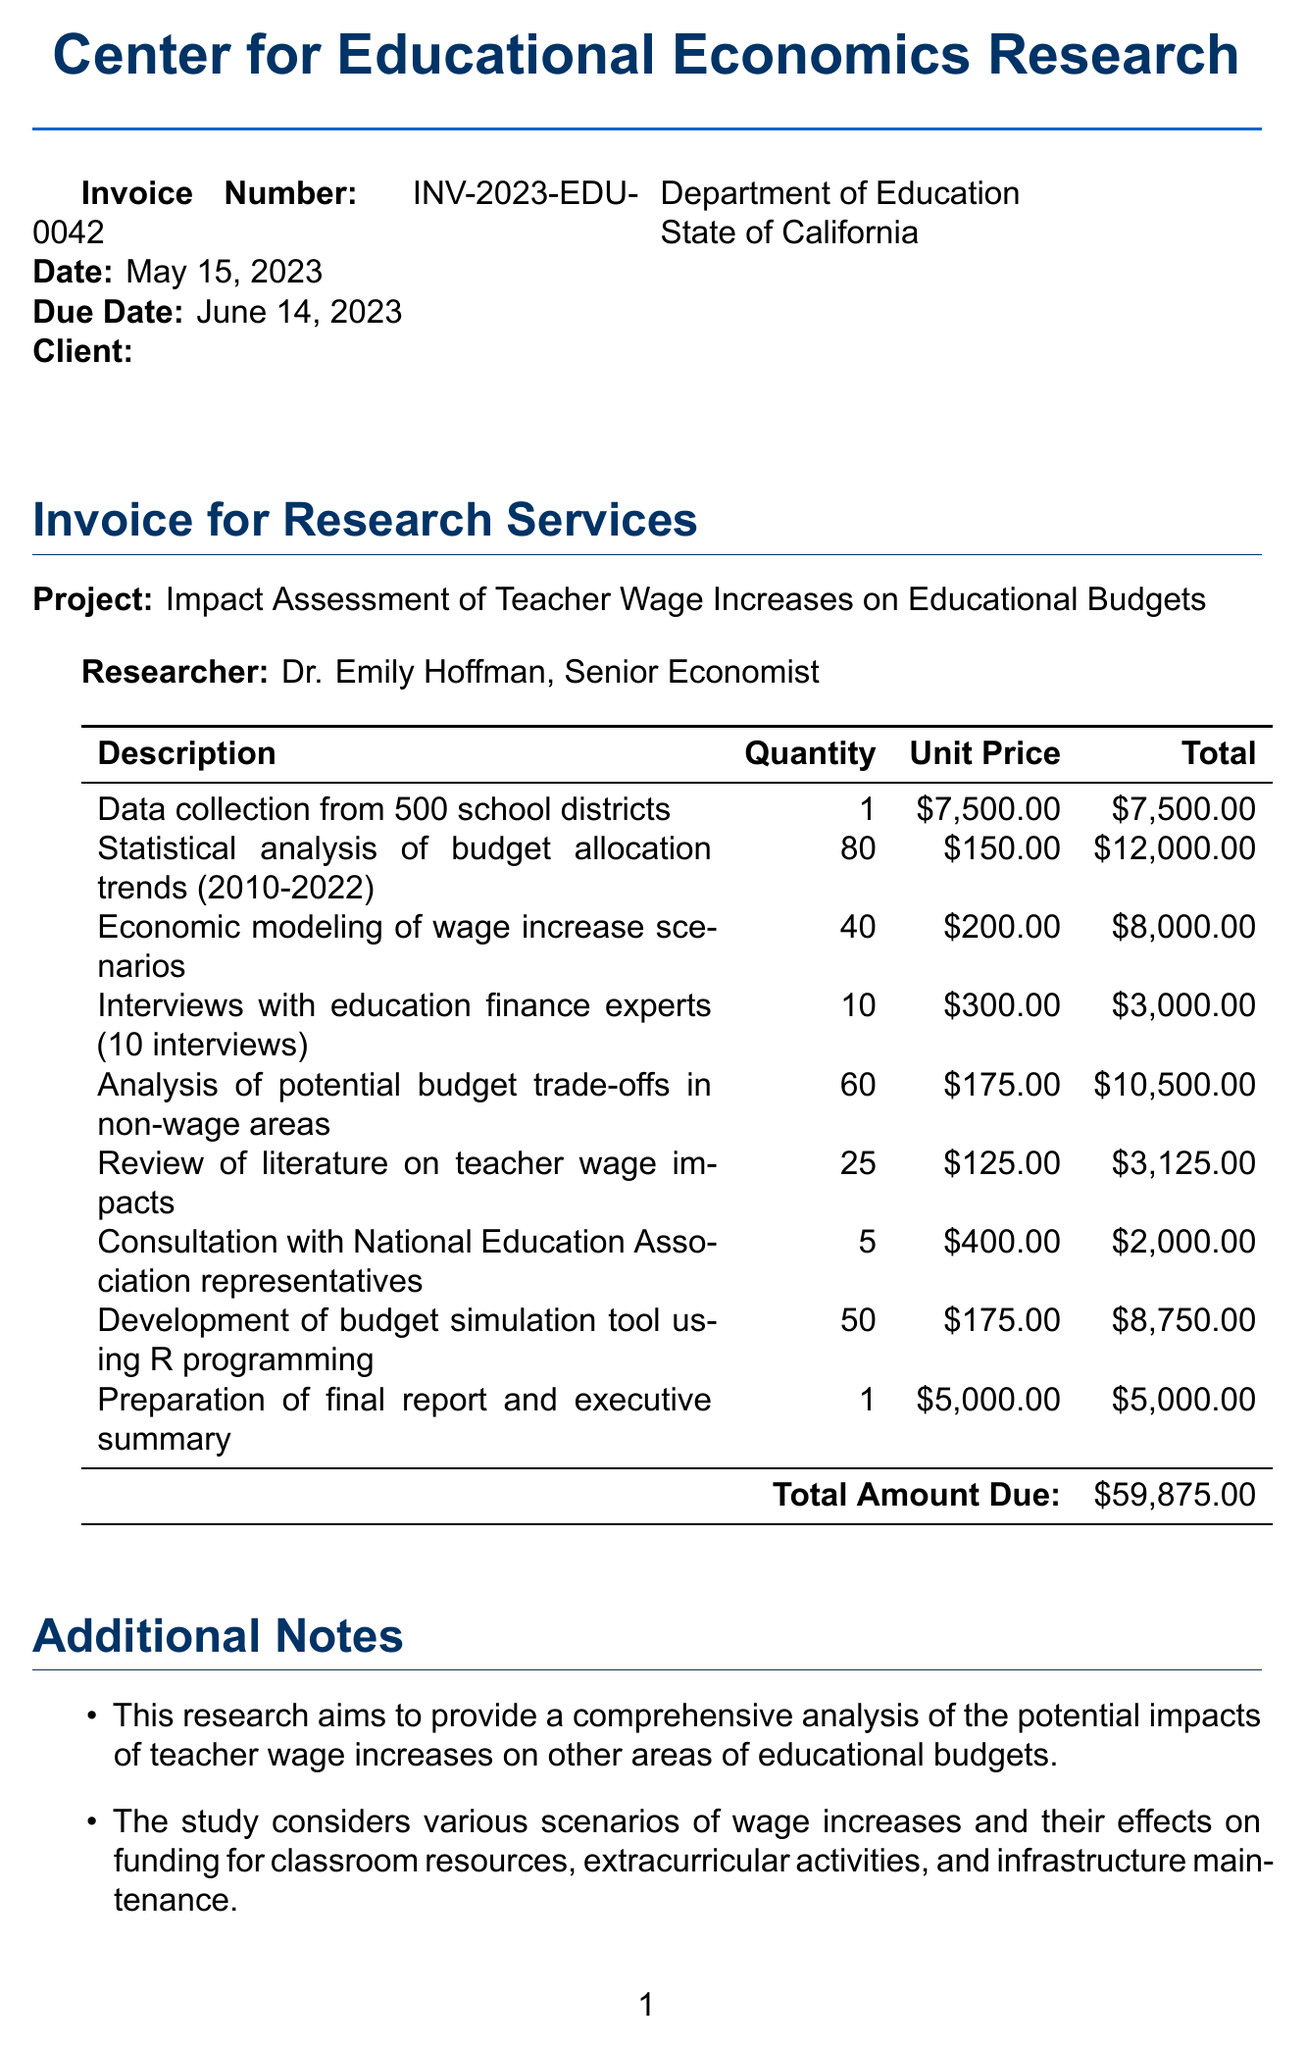What is the invoice number? The invoice number is a unique identifier for the invoice, which is listed in the document.
Answer: INV-2023-EDU-0042 Who is the researcher? The researcher is mentioned in the document and is a key individual for the project.
Answer: Dr. Emily Hoffman What is the total amount due? The total amount due summarizes all costs associated with the services provided in the invoice.
Answer: $59,875.00 How many school districts were involved in the data collection? The document specifies the number of school districts included in the research.
Answer: 500 What is the unit price for statistical analysis of budget allocation trends? The unit price for this service is explicitly stated in the invoice line items.
Answer: $150.00 What type of project is this invoice for? The project title reflects the focus of the research conducted.
Answer: Impact Assessment of Teacher Wage Increases on Educational Budgets How many interviews were conducted with education finance experts? The invoice details the number of interviews that took place for research purposes.
Answer: 10 What are the additional notes about the research? The additional notes provide insights into the objectives of the research presented in the invoice.
Answer: This research aims to provide a comprehensive analysis of the potential impacts of teacher wage increases on other areas of educational budgets Which institution is Dr. Emily Hoffman associated with? The institution name gives context to the researcher’s affiliation relevant to the project.
Answer: Center for Educational Economics Research 